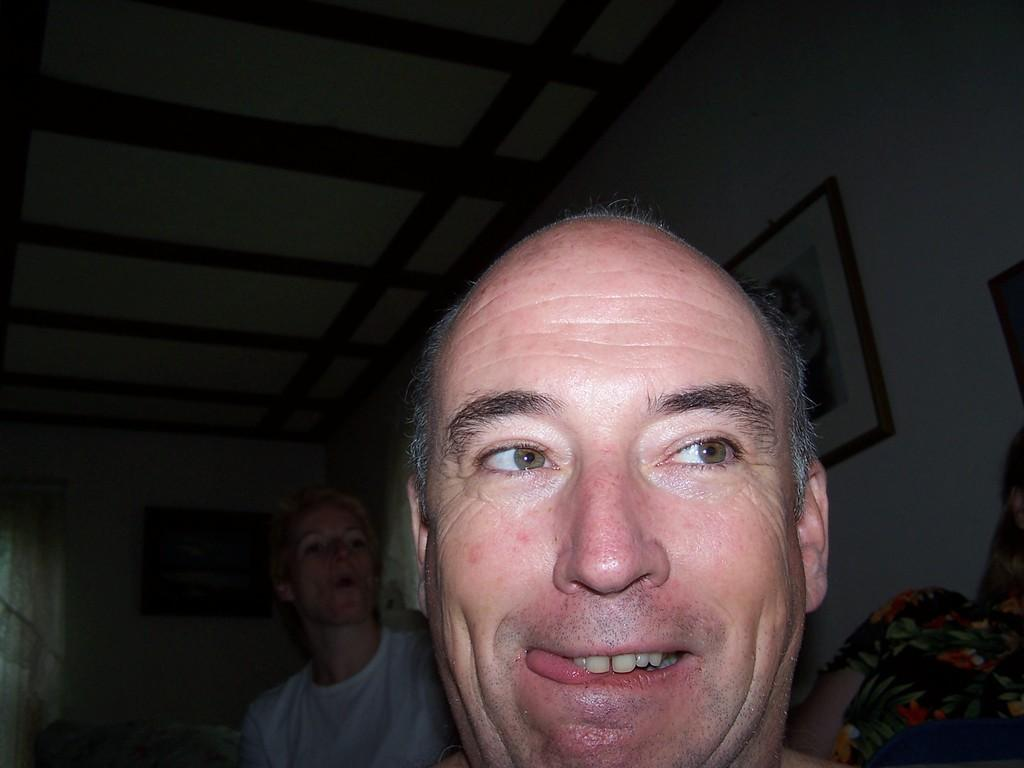What is the main subject in the foreground of the image? There is a man's head in the foreground of the image. Can you describe the other people in the image? There are two other persons in the background of the image. What can be seen on the wall in the image? There are frames on the wall. From where was the image taken? The image is taken from a rooftop. How many steps does the man take in the image? The image does not show the man taking any steps, as it only features his head in the foreground. 